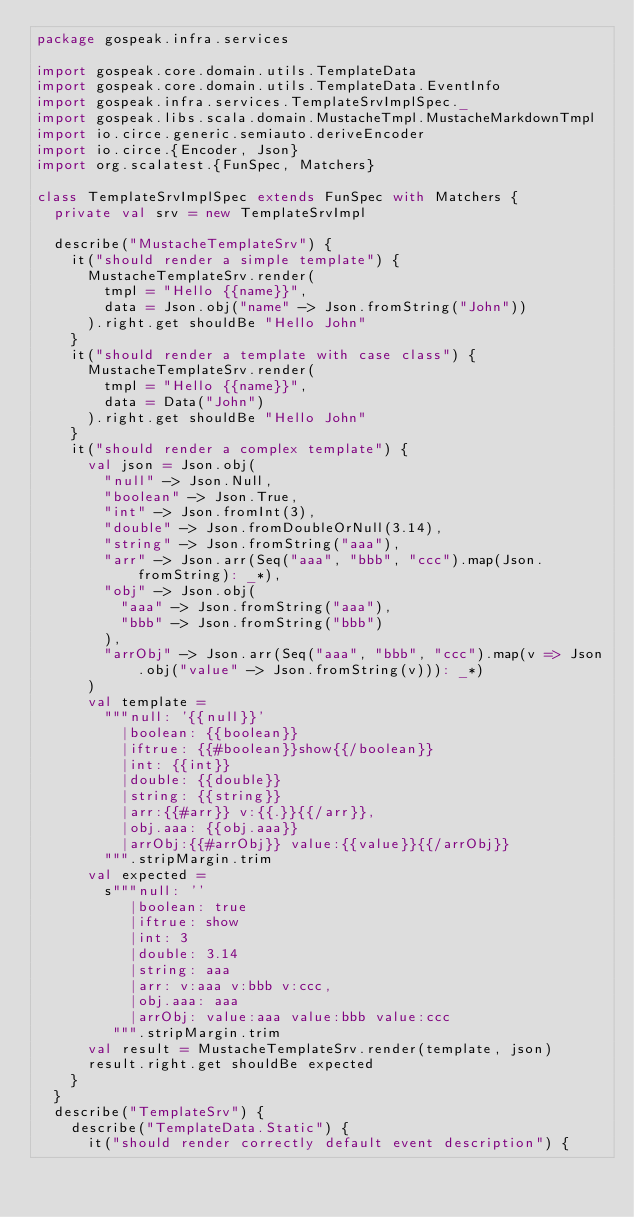Convert code to text. <code><loc_0><loc_0><loc_500><loc_500><_Scala_>package gospeak.infra.services

import gospeak.core.domain.utils.TemplateData
import gospeak.core.domain.utils.TemplateData.EventInfo
import gospeak.infra.services.TemplateSrvImplSpec._
import gospeak.libs.scala.domain.MustacheTmpl.MustacheMarkdownTmpl
import io.circe.generic.semiauto.deriveEncoder
import io.circe.{Encoder, Json}
import org.scalatest.{FunSpec, Matchers}

class TemplateSrvImplSpec extends FunSpec with Matchers {
  private val srv = new TemplateSrvImpl

  describe("MustacheTemplateSrv") {
    it("should render a simple template") {
      MustacheTemplateSrv.render(
        tmpl = "Hello {{name}}",
        data = Json.obj("name" -> Json.fromString("John"))
      ).right.get shouldBe "Hello John"
    }
    it("should render a template with case class") {
      MustacheTemplateSrv.render(
        tmpl = "Hello {{name}}",
        data = Data("John")
      ).right.get shouldBe "Hello John"
    }
    it("should render a complex template") {
      val json = Json.obj(
        "null" -> Json.Null,
        "boolean" -> Json.True,
        "int" -> Json.fromInt(3),
        "double" -> Json.fromDoubleOrNull(3.14),
        "string" -> Json.fromString("aaa"),
        "arr" -> Json.arr(Seq("aaa", "bbb", "ccc").map(Json.fromString): _*),
        "obj" -> Json.obj(
          "aaa" -> Json.fromString("aaa"),
          "bbb" -> Json.fromString("bbb")
        ),
        "arrObj" -> Json.arr(Seq("aaa", "bbb", "ccc").map(v => Json.obj("value" -> Json.fromString(v))): _*)
      )
      val template =
        """null: '{{null}}'
          |boolean: {{boolean}}
          |iftrue: {{#boolean}}show{{/boolean}}
          |int: {{int}}
          |double: {{double}}
          |string: {{string}}
          |arr:{{#arr}} v:{{.}}{{/arr}},
          |obj.aaa: {{obj.aaa}}
          |arrObj:{{#arrObj}} value:{{value}}{{/arrObj}}
        """.stripMargin.trim
      val expected =
        s"""null: ''
           |boolean: true
           |iftrue: show
           |int: 3
           |double: 3.14
           |string: aaa
           |arr: v:aaa v:bbb v:ccc,
           |obj.aaa: aaa
           |arrObj: value:aaa value:bbb value:ccc
         """.stripMargin.trim
      val result = MustacheTemplateSrv.render(template, json)
      result.right.get shouldBe expected
    }
  }
  describe("TemplateSrv") {
    describe("TemplateData.Static") {
      it("should render correctly default event description") {</code> 